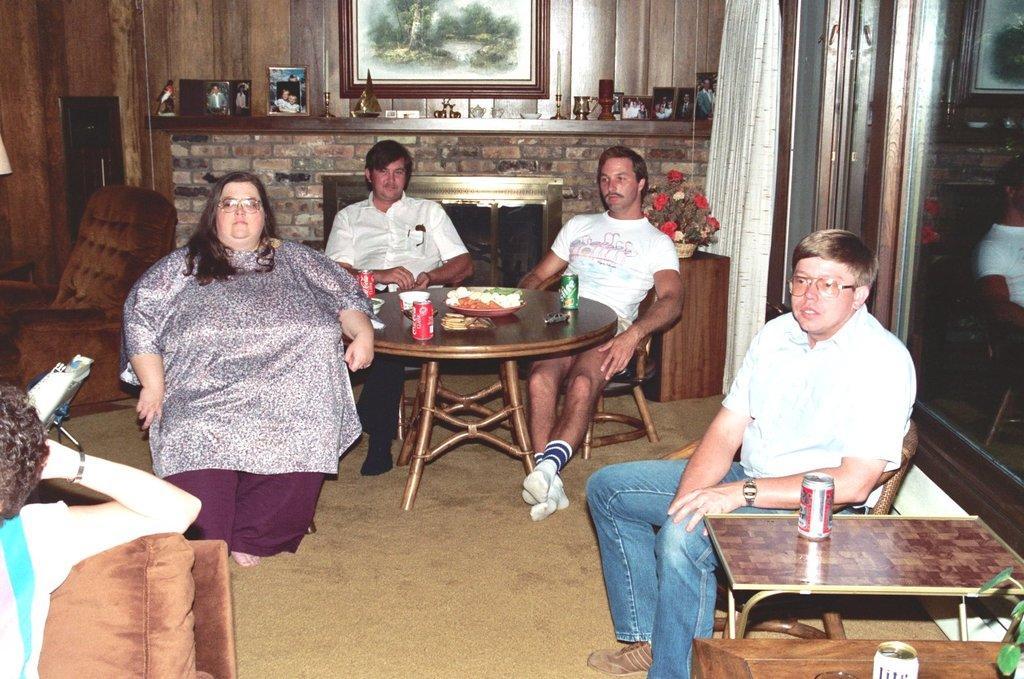In one or two sentences, can you explain what this image depicts? In this image I can see three men and women are sitting on chairs. I can see two of them are wearing specs. I can also see few tables and on these tables I can see few cans, food and plants. I can also see a frame on this wall and here one more person. 